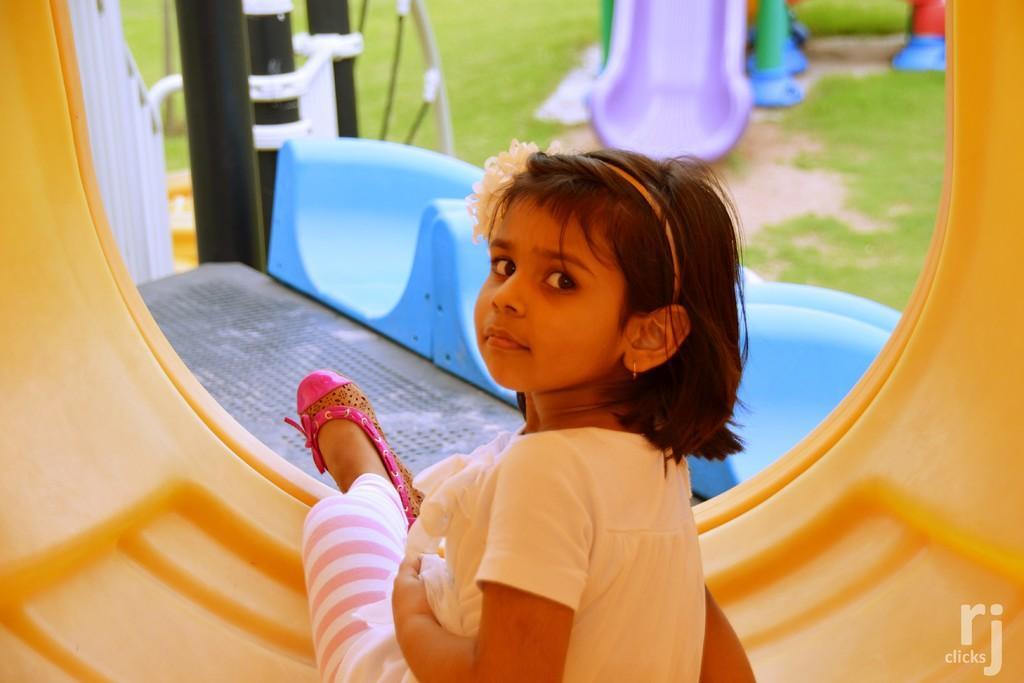Can you describe this image briefly? In the foreground of the picture we can see a girl sitting in a thing. At the top there is a slide. The picture looks like it is taken in a children playground. In the left corner there are poles, hand railing and grass. On the right there is grass. 